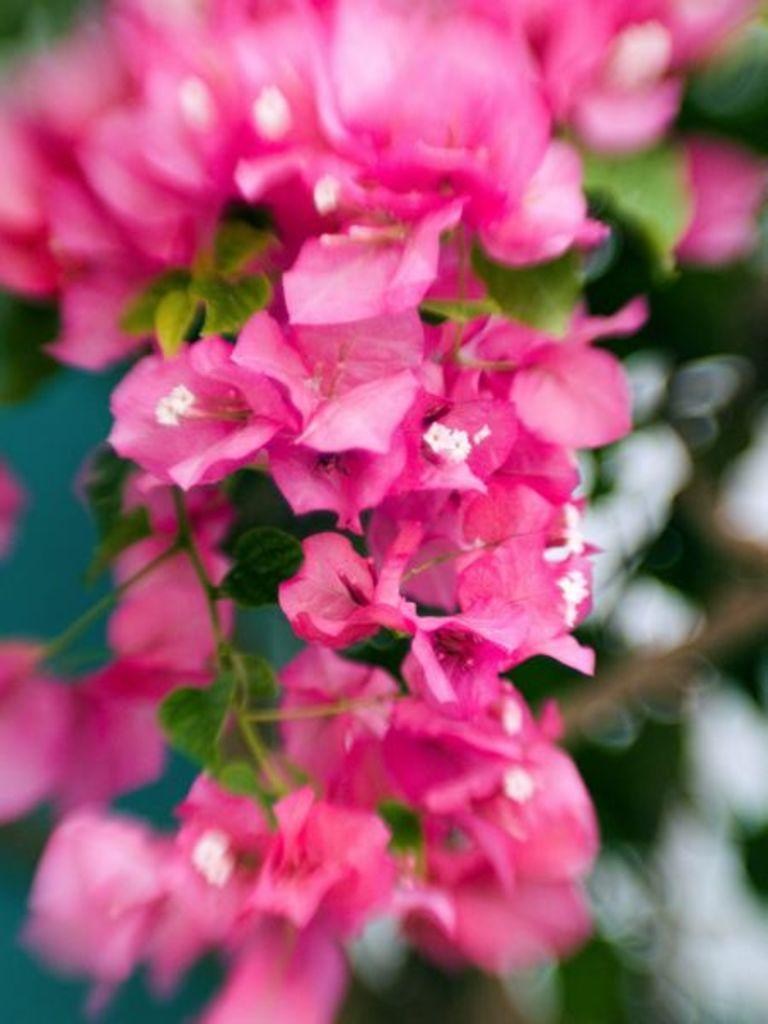What type of flowers are present in the image? There are pink flowers in the image. Can you describe the background of the image? The background of the image is blurred. How many lizards can be seen in the image? There are no lizards present in the image. What type of harbor can be seen in the image? There is no harbor present in the image. 